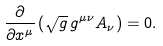Convert formula to latex. <formula><loc_0><loc_0><loc_500><loc_500>\frac { \partial } { \partial x ^ { \mu } } \left ( \sqrt { g } \, g ^ { \mu \nu } A _ { \nu } \right ) = 0 .</formula> 